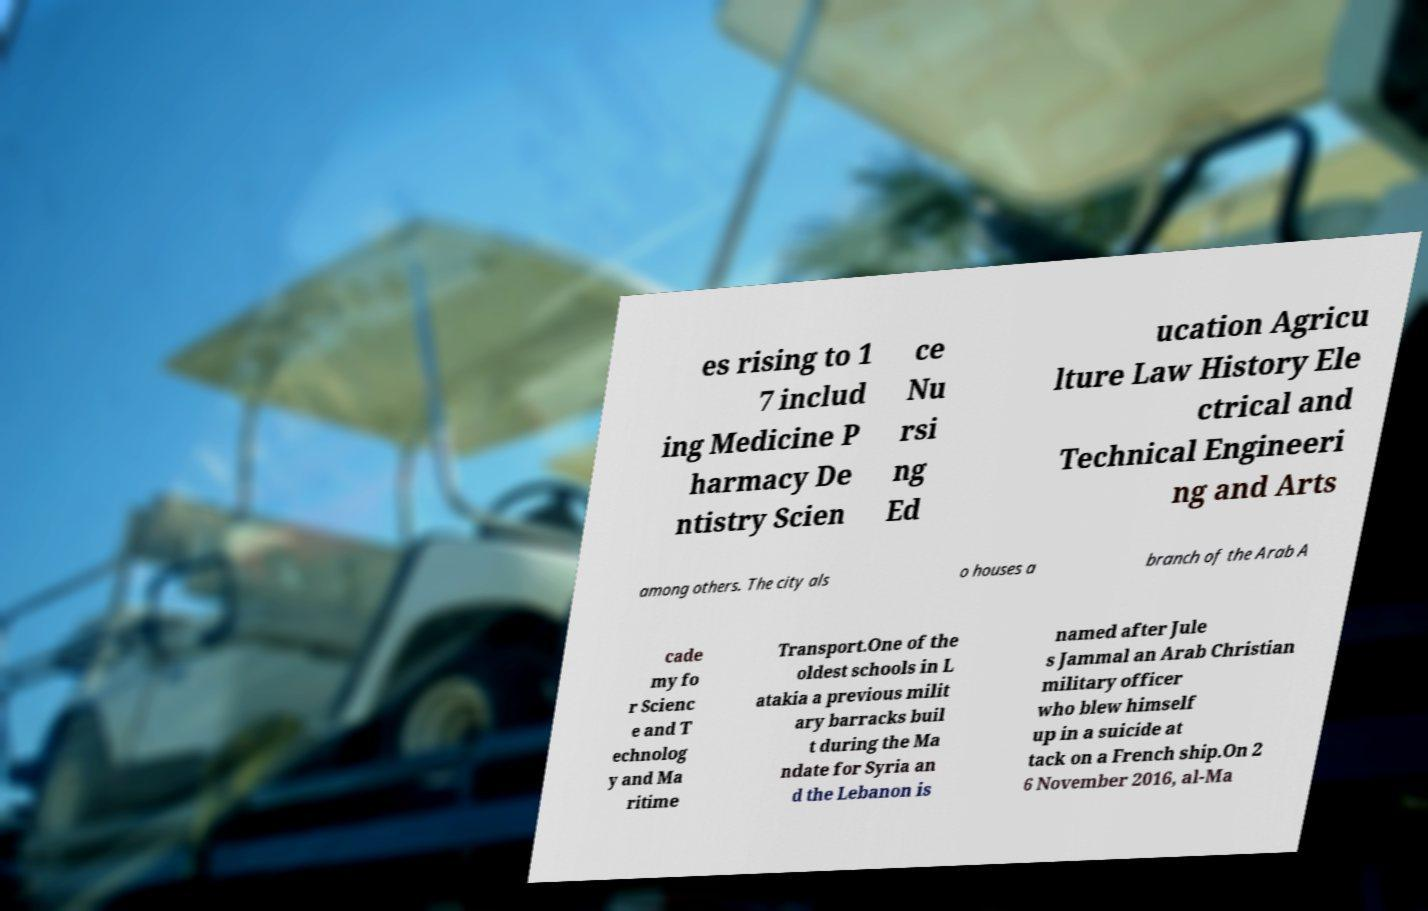I need the written content from this picture converted into text. Can you do that? es rising to 1 7 includ ing Medicine P harmacy De ntistry Scien ce Nu rsi ng Ed ucation Agricu lture Law History Ele ctrical and Technical Engineeri ng and Arts among others. The city als o houses a branch of the Arab A cade my fo r Scienc e and T echnolog y and Ma ritime Transport.One of the oldest schools in L atakia a previous milit ary barracks buil t during the Ma ndate for Syria an d the Lebanon is named after Jule s Jammal an Arab Christian military officer who blew himself up in a suicide at tack on a French ship.On 2 6 November 2016, al-Ma 